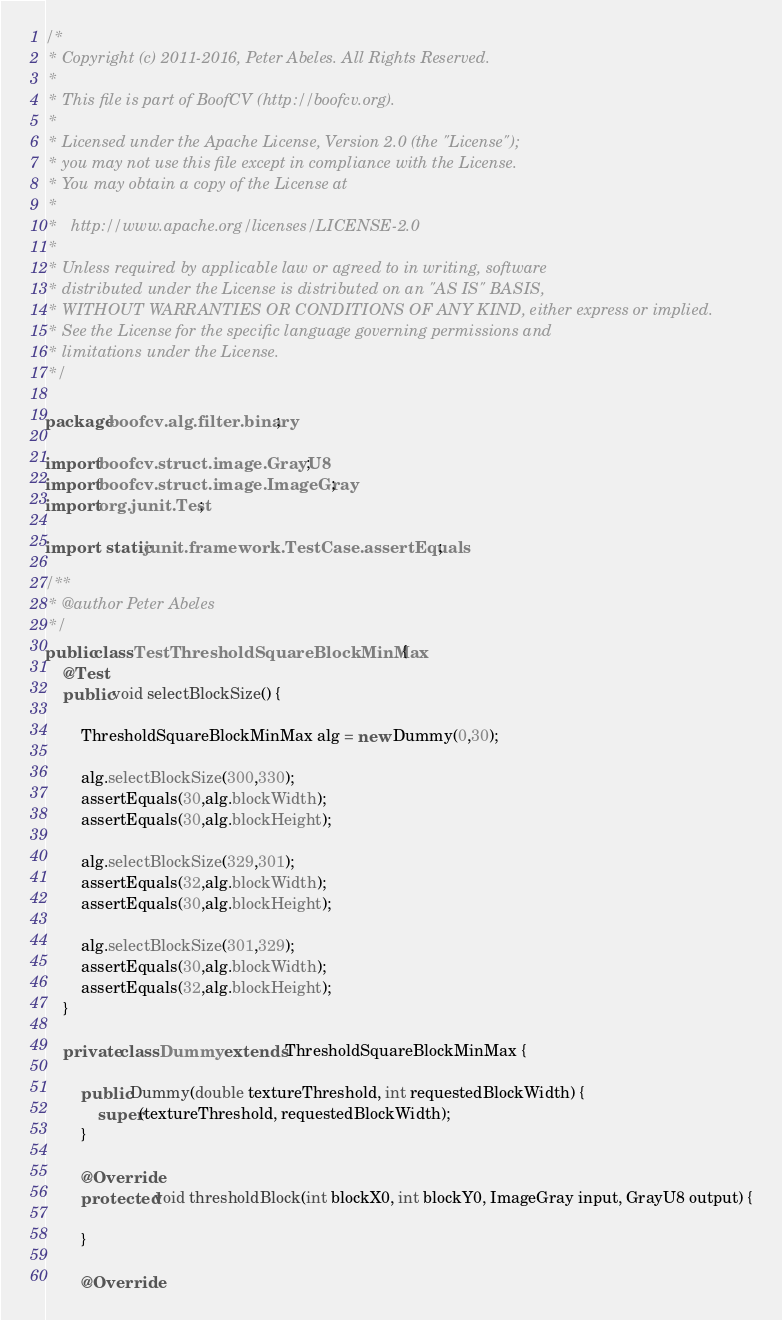Convert code to text. <code><loc_0><loc_0><loc_500><loc_500><_Java_>/*
 * Copyright (c) 2011-2016, Peter Abeles. All Rights Reserved.
 *
 * This file is part of BoofCV (http://boofcv.org).
 *
 * Licensed under the Apache License, Version 2.0 (the "License");
 * you may not use this file except in compliance with the License.
 * You may obtain a copy of the License at
 *
 *   http://www.apache.org/licenses/LICENSE-2.0
 *
 * Unless required by applicable law or agreed to in writing, software
 * distributed under the License is distributed on an "AS IS" BASIS,
 * WITHOUT WARRANTIES OR CONDITIONS OF ANY KIND, either express or implied.
 * See the License for the specific language governing permissions and
 * limitations under the License.
 */

package boofcv.alg.filter.binary;

import boofcv.struct.image.GrayU8;
import boofcv.struct.image.ImageGray;
import org.junit.Test;

import static junit.framework.TestCase.assertEquals;

/**
 * @author Peter Abeles
 */
public class TestThresholdSquareBlockMinMax {
	@Test
	public void selectBlockSize() {

		ThresholdSquareBlockMinMax alg = new Dummy(0,30);

		alg.selectBlockSize(300,330);
		assertEquals(30,alg.blockWidth);
		assertEquals(30,alg.blockHeight);

		alg.selectBlockSize(329,301);
		assertEquals(32,alg.blockWidth);
		assertEquals(30,alg.blockHeight);

		alg.selectBlockSize(301,329);
		assertEquals(30,alg.blockWidth);
		assertEquals(32,alg.blockHeight);
	}

	private class Dummy extends ThresholdSquareBlockMinMax {

		public Dummy(double textureThreshold, int requestedBlockWidth) {
			super(textureThreshold, requestedBlockWidth);
		}

		@Override
		protected void thresholdBlock(int blockX0, int blockY0, ImageGray input, GrayU8 output) {

		}

		@Override</code> 